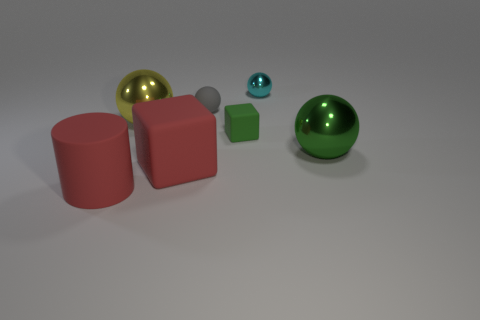What material is the large object that is the same color as the small matte block?
Your answer should be very brief. Metal. What number of rubber cylinders have the same size as the cyan ball?
Keep it short and to the point. 0. There is a gray thing that is the same shape as the cyan shiny object; what material is it?
Keep it short and to the point. Rubber. How many objects are big metallic spheres left of the green shiny sphere or cubes in front of the tiny green matte object?
Ensure brevity in your answer.  2. There is a cyan metallic object; is its shape the same as the large metal object in front of the tiny green rubber object?
Offer a very short reply. Yes. What is the shape of the small green object behind the big red rubber block in front of the metal object on the right side of the tiny metallic object?
Offer a terse response. Cube. How many other objects are the same material as the tiny green object?
Provide a short and direct response. 3. What number of things are balls that are to the left of the gray ball or big yellow blocks?
Give a very brief answer. 1. The red matte thing to the right of the metallic sphere that is left of the small gray ball is what shape?
Make the answer very short. Cube. Does the red thing that is on the right side of the rubber cylinder have the same shape as the yellow shiny thing?
Your answer should be very brief. No. 